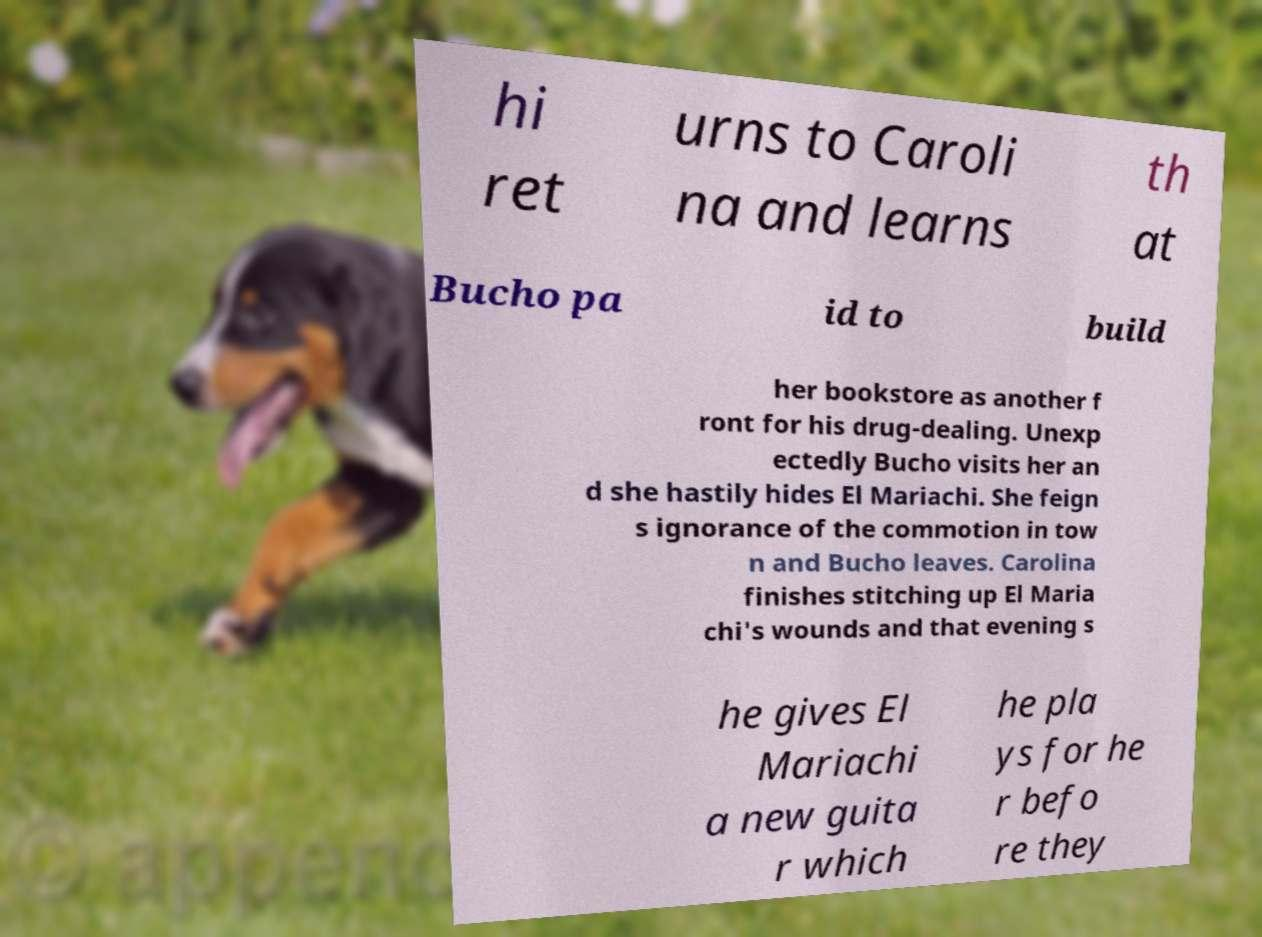Could you assist in decoding the text presented in this image and type it out clearly? hi ret urns to Caroli na and learns th at Bucho pa id to build her bookstore as another f ront for his drug-dealing. Unexp ectedly Bucho visits her an d she hastily hides El Mariachi. She feign s ignorance of the commotion in tow n and Bucho leaves. Carolina finishes stitching up El Maria chi's wounds and that evening s he gives El Mariachi a new guita r which he pla ys for he r befo re they 